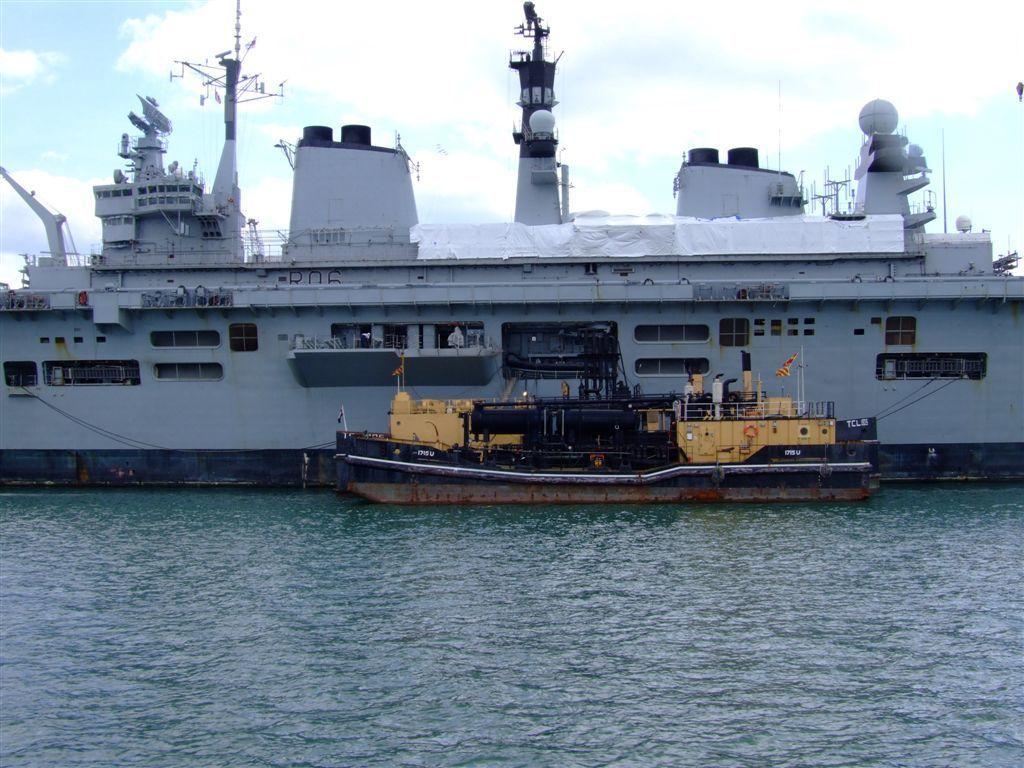Can you describe this image briefly? We can see ships above the water. In the background we can see sky is cloudy. 